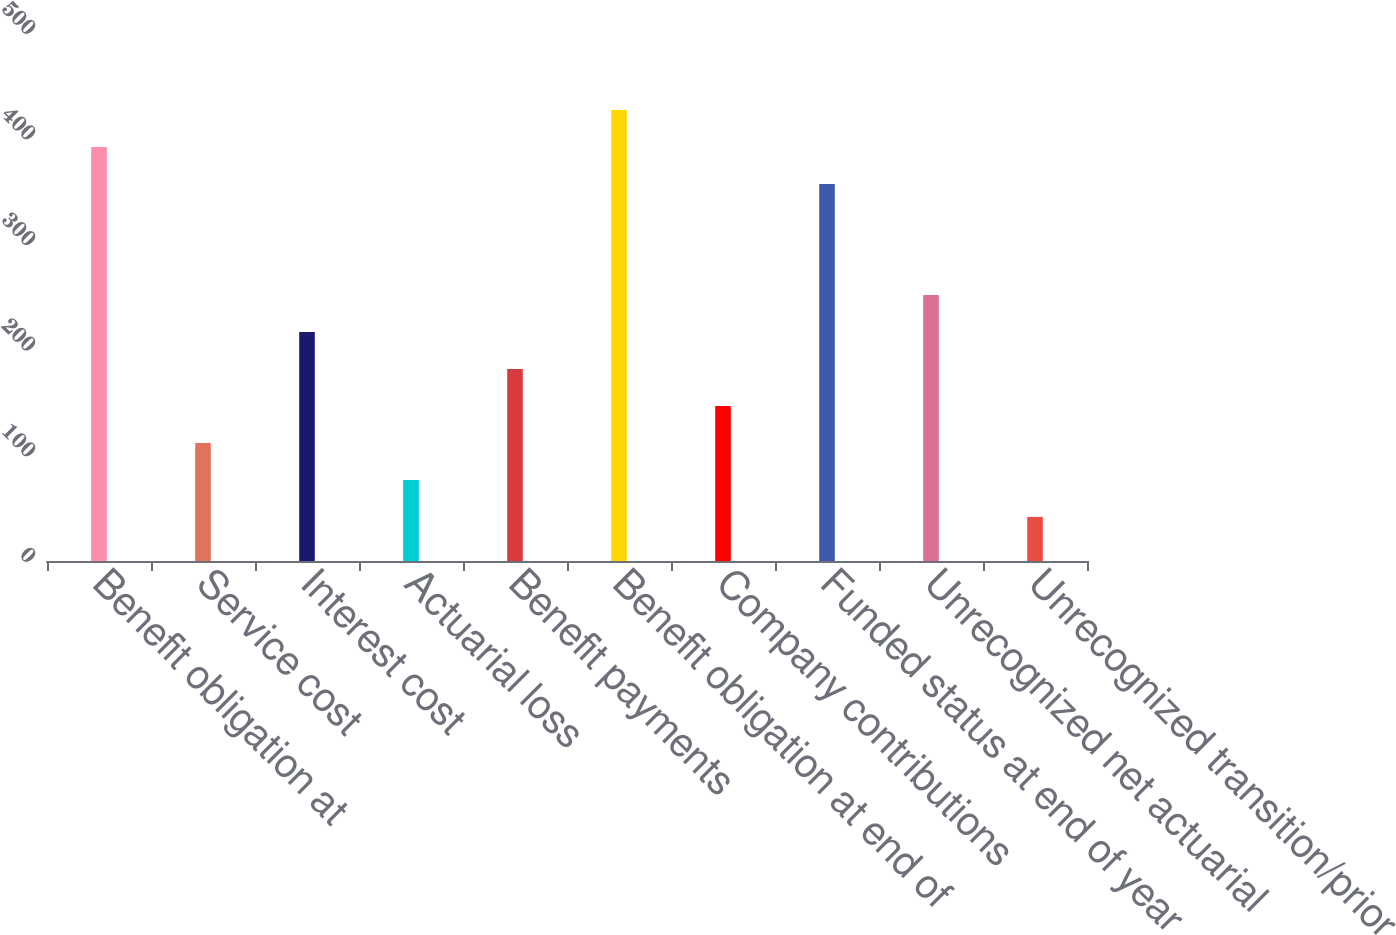<chart> <loc_0><loc_0><loc_500><loc_500><bar_chart><fcel>Benefit obligation at<fcel>Service cost<fcel>Interest cost<fcel>Actuarial loss<fcel>Benefit payments<fcel>Benefit obligation at end of<fcel>Company contributions<fcel>Funded status at end of year<fcel>Unrecognized net actuarial<fcel>Unrecognized transition/prior<nl><fcel>392.13<fcel>111.81<fcel>216.93<fcel>76.77<fcel>181.89<fcel>427.17<fcel>146.85<fcel>357.09<fcel>251.97<fcel>41.73<nl></chart> 